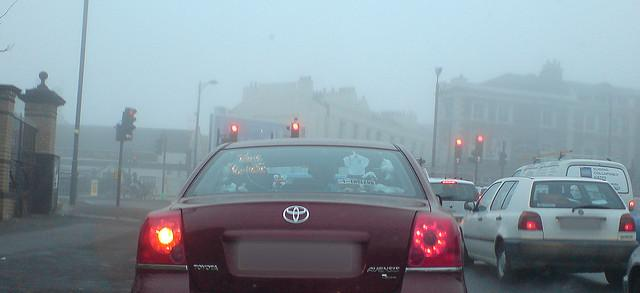Why are the license plates invisible? Please explain your reasoning. blurred. You can't see the numbers clearly. 